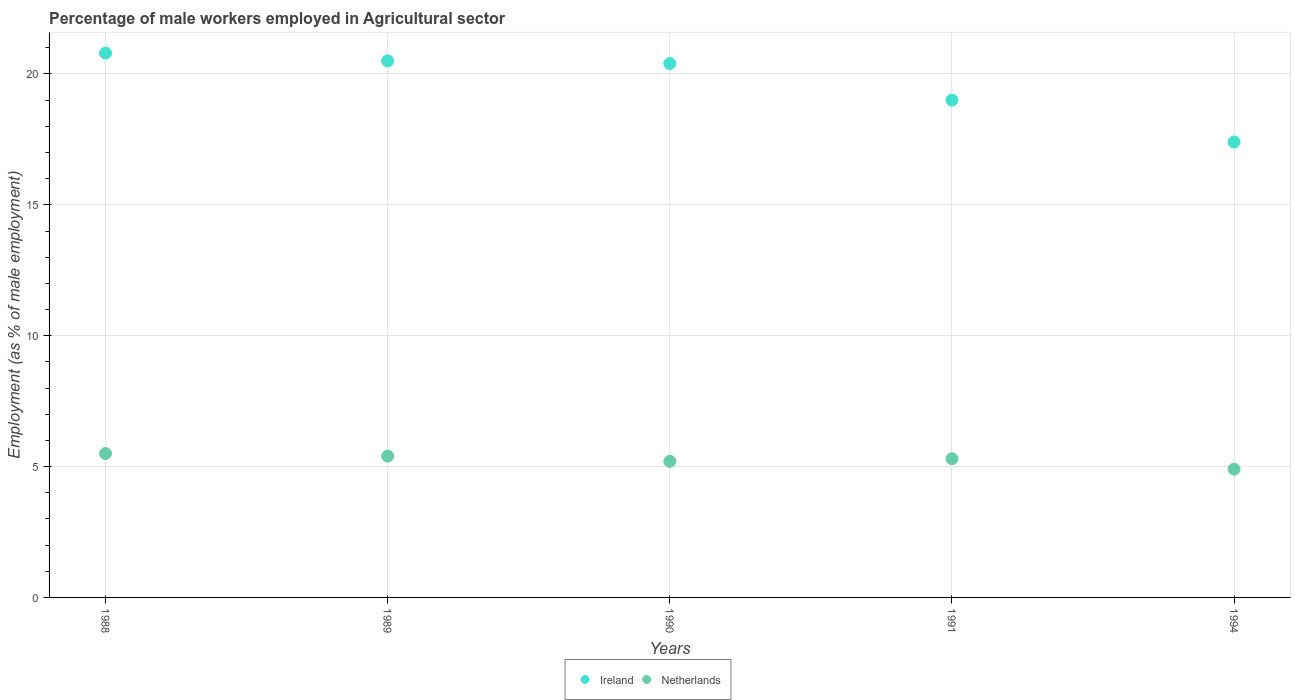How many different coloured dotlines are there?
Provide a succinct answer. 2. Is the number of dotlines equal to the number of legend labels?
Provide a succinct answer. Yes. What is the percentage of male workers employed in Agricultural sector in Ireland in 1994?
Provide a short and direct response. 17.4. Across all years, what is the maximum percentage of male workers employed in Agricultural sector in Ireland?
Offer a terse response. 20.8. Across all years, what is the minimum percentage of male workers employed in Agricultural sector in Ireland?
Your answer should be compact. 17.4. In which year was the percentage of male workers employed in Agricultural sector in Netherlands maximum?
Offer a terse response. 1988. What is the total percentage of male workers employed in Agricultural sector in Ireland in the graph?
Your answer should be compact. 98.1. What is the difference between the percentage of male workers employed in Agricultural sector in Ireland in 1990 and that in 1991?
Offer a very short reply. 1.4. What is the average percentage of male workers employed in Agricultural sector in Netherlands per year?
Give a very brief answer. 5.26. In the year 1990, what is the difference between the percentage of male workers employed in Agricultural sector in Netherlands and percentage of male workers employed in Agricultural sector in Ireland?
Ensure brevity in your answer.  -15.2. In how many years, is the percentage of male workers employed in Agricultural sector in Netherlands greater than 18 %?
Your answer should be very brief. 0. What is the ratio of the percentage of male workers employed in Agricultural sector in Netherlands in 1988 to that in 1990?
Your answer should be compact. 1.06. What is the difference between the highest and the second highest percentage of male workers employed in Agricultural sector in Netherlands?
Provide a short and direct response. 0.1. What is the difference between the highest and the lowest percentage of male workers employed in Agricultural sector in Ireland?
Make the answer very short. 3.4. Is the sum of the percentage of male workers employed in Agricultural sector in Ireland in 1988 and 1989 greater than the maximum percentage of male workers employed in Agricultural sector in Netherlands across all years?
Provide a succinct answer. Yes. Does the percentage of male workers employed in Agricultural sector in Ireland monotonically increase over the years?
Ensure brevity in your answer.  No. What is the difference between two consecutive major ticks on the Y-axis?
Your answer should be compact. 5. Are the values on the major ticks of Y-axis written in scientific E-notation?
Offer a terse response. No. What is the title of the graph?
Give a very brief answer. Percentage of male workers employed in Agricultural sector. What is the label or title of the Y-axis?
Offer a terse response. Employment (as % of male employment). What is the Employment (as % of male employment) in Ireland in 1988?
Ensure brevity in your answer.  20.8. What is the Employment (as % of male employment) in Netherlands in 1988?
Your response must be concise. 5.5. What is the Employment (as % of male employment) in Netherlands in 1989?
Your response must be concise. 5.4. What is the Employment (as % of male employment) of Ireland in 1990?
Provide a short and direct response. 20.4. What is the Employment (as % of male employment) in Netherlands in 1990?
Provide a short and direct response. 5.2. What is the Employment (as % of male employment) of Netherlands in 1991?
Provide a short and direct response. 5.3. What is the Employment (as % of male employment) of Ireland in 1994?
Give a very brief answer. 17.4. What is the Employment (as % of male employment) of Netherlands in 1994?
Your answer should be very brief. 4.9. Across all years, what is the maximum Employment (as % of male employment) in Ireland?
Your response must be concise. 20.8. Across all years, what is the minimum Employment (as % of male employment) in Ireland?
Make the answer very short. 17.4. Across all years, what is the minimum Employment (as % of male employment) in Netherlands?
Offer a terse response. 4.9. What is the total Employment (as % of male employment) in Ireland in the graph?
Make the answer very short. 98.1. What is the total Employment (as % of male employment) in Netherlands in the graph?
Provide a succinct answer. 26.3. What is the difference between the Employment (as % of male employment) of Ireland in 1988 and that in 1989?
Provide a succinct answer. 0.3. What is the difference between the Employment (as % of male employment) of Netherlands in 1988 and that in 1989?
Provide a succinct answer. 0.1. What is the difference between the Employment (as % of male employment) in Ireland in 1988 and that in 1994?
Offer a terse response. 3.4. What is the difference between the Employment (as % of male employment) in Ireland in 1989 and that in 1990?
Your answer should be compact. 0.1. What is the difference between the Employment (as % of male employment) of Netherlands in 1989 and that in 1990?
Keep it short and to the point. 0.2. What is the difference between the Employment (as % of male employment) in Ireland in 1989 and that in 1991?
Your response must be concise. 1.5. What is the difference between the Employment (as % of male employment) of Ireland in 1989 and that in 1994?
Your response must be concise. 3.1. What is the difference between the Employment (as % of male employment) of Netherlands in 1989 and that in 1994?
Your answer should be compact. 0.5. What is the difference between the Employment (as % of male employment) in Ireland in 1990 and that in 1991?
Offer a terse response. 1.4. What is the difference between the Employment (as % of male employment) in Netherlands in 1990 and that in 1991?
Your answer should be compact. -0.1. What is the difference between the Employment (as % of male employment) in Netherlands in 1990 and that in 1994?
Provide a short and direct response. 0.3. What is the difference between the Employment (as % of male employment) in Ireland in 1988 and the Employment (as % of male employment) in Netherlands in 1989?
Give a very brief answer. 15.4. What is the difference between the Employment (as % of male employment) in Ireland in 1988 and the Employment (as % of male employment) in Netherlands in 1991?
Make the answer very short. 15.5. What is the difference between the Employment (as % of male employment) of Ireland in 1989 and the Employment (as % of male employment) of Netherlands in 1990?
Give a very brief answer. 15.3. What is the difference between the Employment (as % of male employment) in Ireland in 1989 and the Employment (as % of male employment) in Netherlands in 1994?
Provide a short and direct response. 15.6. What is the difference between the Employment (as % of male employment) in Ireland in 1990 and the Employment (as % of male employment) in Netherlands in 1991?
Provide a succinct answer. 15.1. What is the difference between the Employment (as % of male employment) of Ireland in 1990 and the Employment (as % of male employment) of Netherlands in 1994?
Provide a short and direct response. 15.5. What is the difference between the Employment (as % of male employment) in Ireland in 1991 and the Employment (as % of male employment) in Netherlands in 1994?
Your answer should be very brief. 14.1. What is the average Employment (as % of male employment) in Ireland per year?
Your response must be concise. 19.62. What is the average Employment (as % of male employment) in Netherlands per year?
Make the answer very short. 5.26. In the year 1994, what is the difference between the Employment (as % of male employment) of Ireland and Employment (as % of male employment) of Netherlands?
Provide a short and direct response. 12.5. What is the ratio of the Employment (as % of male employment) of Ireland in 1988 to that in 1989?
Provide a short and direct response. 1.01. What is the ratio of the Employment (as % of male employment) of Netherlands in 1988 to that in 1989?
Your answer should be compact. 1.02. What is the ratio of the Employment (as % of male employment) in Ireland in 1988 to that in 1990?
Give a very brief answer. 1.02. What is the ratio of the Employment (as % of male employment) in Netherlands in 1988 to that in 1990?
Your answer should be compact. 1.06. What is the ratio of the Employment (as % of male employment) of Ireland in 1988 to that in 1991?
Give a very brief answer. 1.09. What is the ratio of the Employment (as % of male employment) in Netherlands in 1988 to that in 1991?
Offer a very short reply. 1.04. What is the ratio of the Employment (as % of male employment) in Ireland in 1988 to that in 1994?
Offer a very short reply. 1.2. What is the ratio of the Employment (as % of male employment) of Netherlands in 1988 to that in 1994?
Provide a succinct answer. 1.12. What is the ratio of the Employment (as % of male employment) of Ireland in 1989 to that in 1990?
Provide a succinct answer. 1. What is the ratio of the Employment (as % of male employment) in Netherlands in 1989 to that in 1990?
Make the answer very short. 1.04. What is the ratio of the Employment (as % of male employment) in Ireland in 1989 to that in 1991?
Offer a very short reply. 1.08. What is the ratio of the Employment (as % of male employment) in Netherlands in 1989 to that in 1991?
Your answer should be very brief. 1.02. What is the ratio of the Employment (as % of male employment) of Ireland in 1989 to that in 1994?
Your response must be concise. 1.18. What is the ratio of the Employment (as % of male employment) in Netherlands in 1989 to that in 1994?
Your answer should be very brief. 1.1. What is the ratio of the Employment (as % of male employment) in Ireland in 1990 to that in 1991?
Ensure brevity in your answer.  1.07. What is the ratio of the Employment (as % of male employment) in Netherlands in 1990 to that in 1991?
Give a very brief answer. 0.98. What is the ratio of the Employment (as % of male employment) in Ireland in 1990 to that in 1994?
Offer a terse response. 1.17. What is the ratio of the Employment (as % of male employment) in Netherlands in 1990 to that in 1994?
Make the answer very short. 1.06. What is the ratio of the Employment (as % of male employment) of Ireland in 1991 to that in 1994?
Offer a very short reply. 1.09. What is the ratio of the Employment (as % of male employment) of Netherlands in 1991 to that in 1994?
Your answer should be very brief. 1.08. What is the difference between the highest and the second highest Employment (as % of male employment) of Ireland?
Make the answer very short. 0.3. 